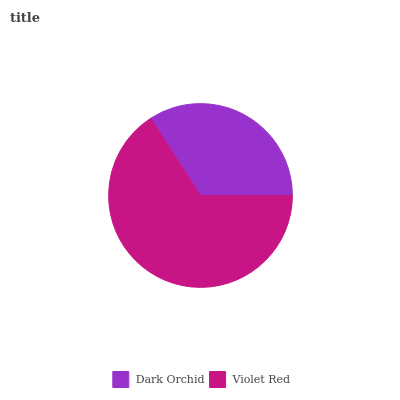Is Dark Orchid the minimum?
Answer yes or no. Yes. Is Violet Red the maximum?
Answer yes or no. Yes. Is Violet Red the minimum?
Answer yes or no. No. Is Violet Red greater than Dark Orchid?
Answer yes or no. Yes. Is Dark Orchid less than Violet Red?
Answer yes or no. Yes. Is Dark Orchid greater than Violet Red?
Answer yes or no. No. Is Violet Red less than Dark Orchid?
Answer yes or no. No. Is Violet Red the high median?
Answer yes or no. Yes. Is Dark Orchid the low median?
Answer yes or no. Yes. Is Dark Orchid the high median?
Answer yes or no. No. Is Violet Red the low median?
Answer yes or no. No. 